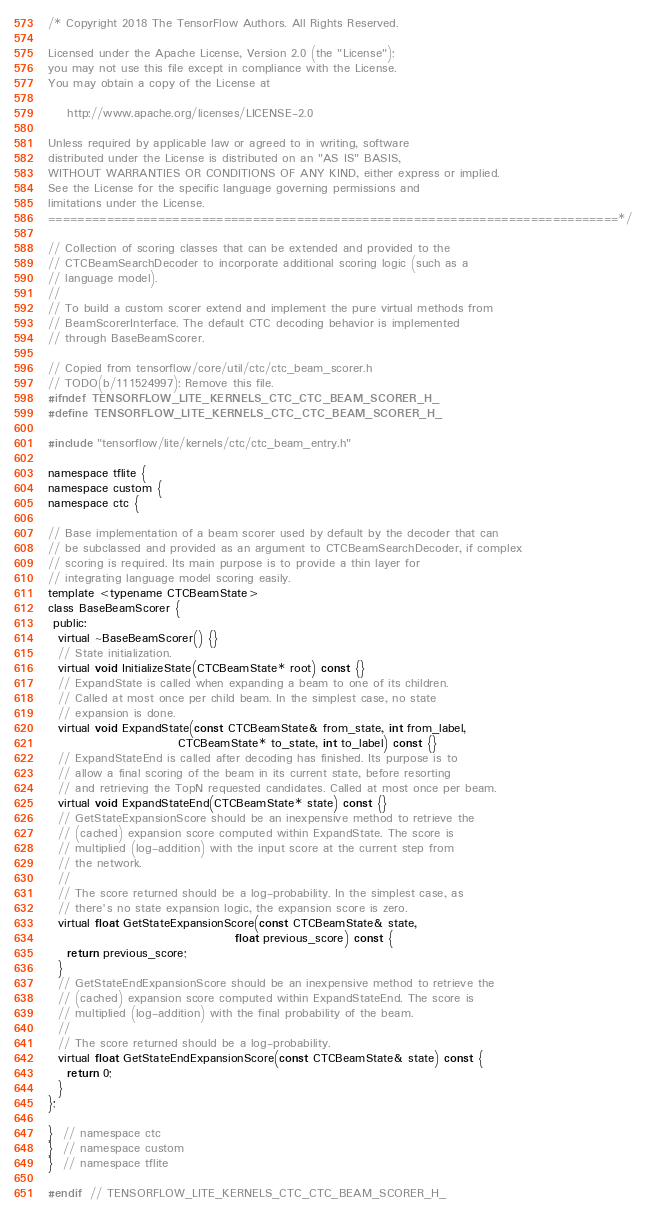<code> <loc_0><loc_0><loc_500><loc_500><_C_>/* Copyright 2018 The TensorFlow Authors. All Rights Reserved.

Licensed under the Apache License, Version 2.0 (the "License");
you may not use this file except in compliance with the License.
You may obtain a copy of the License at

    http://www.apache.org/licenses/LICENSE-2.0

Unless required by applicable law or agreed to in writing, software
distributed under the License is distributed on an "AS IS" BASIS,
WITHOUT WARRANTIES OR CONDITIONS OF ANY KIND, either express or implied.
See the License for the specific language governing permissions and
limitations under the License.
==============================================================================*/

// Collection of scoring classes that can be extended and provided to the
// CTCBeamSearchDecoder to incorporate additional scoring logic (such as a
// language model).
//
// To build a custom scorer extend and implement the pure virtual methods from
// BeamScorerInterface. The default CTC decoding behavior is implemented
// through BaseBeamScorer.

// Copied from tensorflow/core/util/ctc/ctc_beam_scorer.h
// TODO(b/111524997): Remove this file.
#ifndef TENSORFLOW_LITE_KERNELS_CTC_CTC_BEAM_SCORER_H_
#define TENSORFLOW_LITE_KERNELS_CTC_CTC_BEAM_SCORER_H_

#include "tensorflow/lite/kernels/ctc/ctc_beam_entry.h"

namespace tflite {
namespace custom {
namespace ctc {

// Base implementation of a beam scorer used by default by the decoder that can
// be subclassed and provided as an argument to CTCBeamSearchDecoder, if complex
// scoring is required. Its main purpose is to provide a thin layer for
// integrating language model scoring easily.
template <typename CTCBeamState>
class BaseBeamScorer {
 public:
  virtual ~BaseBeamScorer() {}
  // State initialization.
  virtual void InitializeState(CTCBeamState* root) const {}
  // ExpandState is called when expanding a beam to one of its children.
  // Called at most once per child beam. In the simplest case, no state
  // expansion is done.
  virtual void ExpandState(const CTCBeamState& from_state, int from_label,
                           CTCBeamState* to_state, int to_label) const {}
  // ExpandStateEnd is called after decoding has finished. Its purpose is to
  // allow a final scoring of the beam in its current state, before resorting
  // and retrieving the TopN requested candidates. Called at most once per beam.
  virtual void ExpandStateEnd(CTCBeamState* state) const {}
  // GetStateExpansionScore should be an inexpensive method to retrieve the
  // (cached) expansion score computed within ExpandState. The score is
  // multiplied (log-addition) with the input score at the current step from
  // the network.
  //
  // The score returned should be a log-probability. In the simplest case, as
  // there's no state expansion logic, the expansion score is zero.
  virtual float GetStateExpansionScore(const CTCBeamState& state,
                                       float previous_score) const {
    return previous_score;
  }
  // GetStateEndExpansionScore should be an inexpensive method to retrieve the
  // (cached) expansion score computed within ExpandStateEnd. The score is
  // multiplied (log-addition) with the final probability of the beam.
  //
  // The score returned should be a log-probability.
  virtual float GetStateEndExpansionScore(const CTCBeamState& state) const {
    return 0;
  }
};

}  // namespace ctc
}  // namespace custom
}  // namespace tflite

#endif  // TENSORFLOW_LITE_KERNELS_CTC_CTC_BEAM_SCORER_H_
</code> 